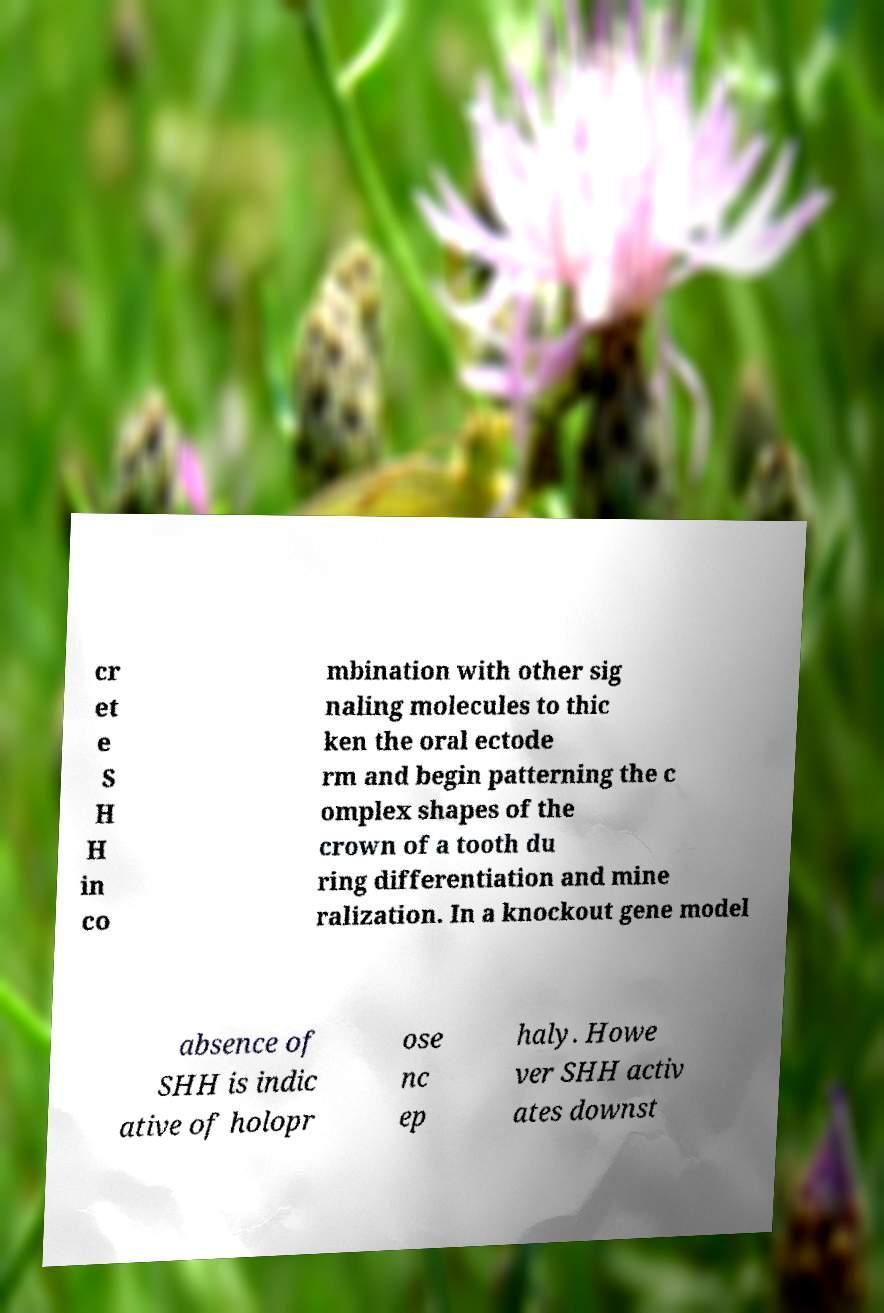Could you extract and type out the text from this image? cr et e S H H in co mbination with other sig naling molecules to thic ken the oral ectode rm and begin patterning the c omplex shapes of the crown of a tooth du ring differentiation and mine ralization. In a knockout gene model absence of SHH is indic ative of holopr ose nc ep haly. Howe ver SHH activ ates downst 